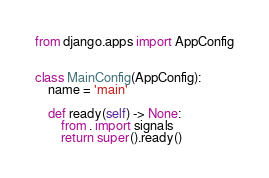<code> <loc_0><loc_0><loc_500><loc_500><_Python_>from django.apps import AppConfig


class MainConfig(AppConfig):
    name = 'main'

    def ready(self) -> None:
        from . import signals
        return super().ready()</code> 